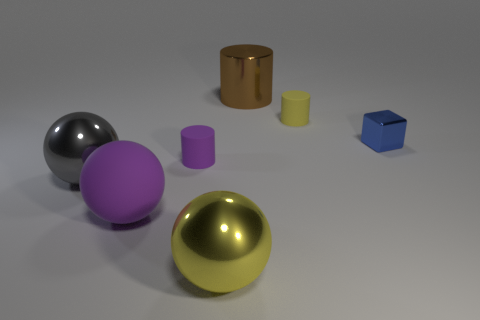Subtract all metallic spheres. How many spheres are left? 1 Add 1 big blocks. How many objects exist? 8 Subtract all purple cylinders. How many cylinders are left? 2 Subtract all blocks. How many objects are left? 6 Subtract 1 yellow spheres. How many objects are left? 6 Subtract 3 cylinders. How many cylinders are left? 0 Subtract all green cylinders. Subtract all brown blocks. How many cylinders are left? 3 Subtract all large matte objects. Subtract all big yellow things. How many objects are left? 5 Add 7 small purple matte cylinders. How many small purple matte cylinders are left? 8 Add 3 large purple balls. How many large purple balls exist? 4 